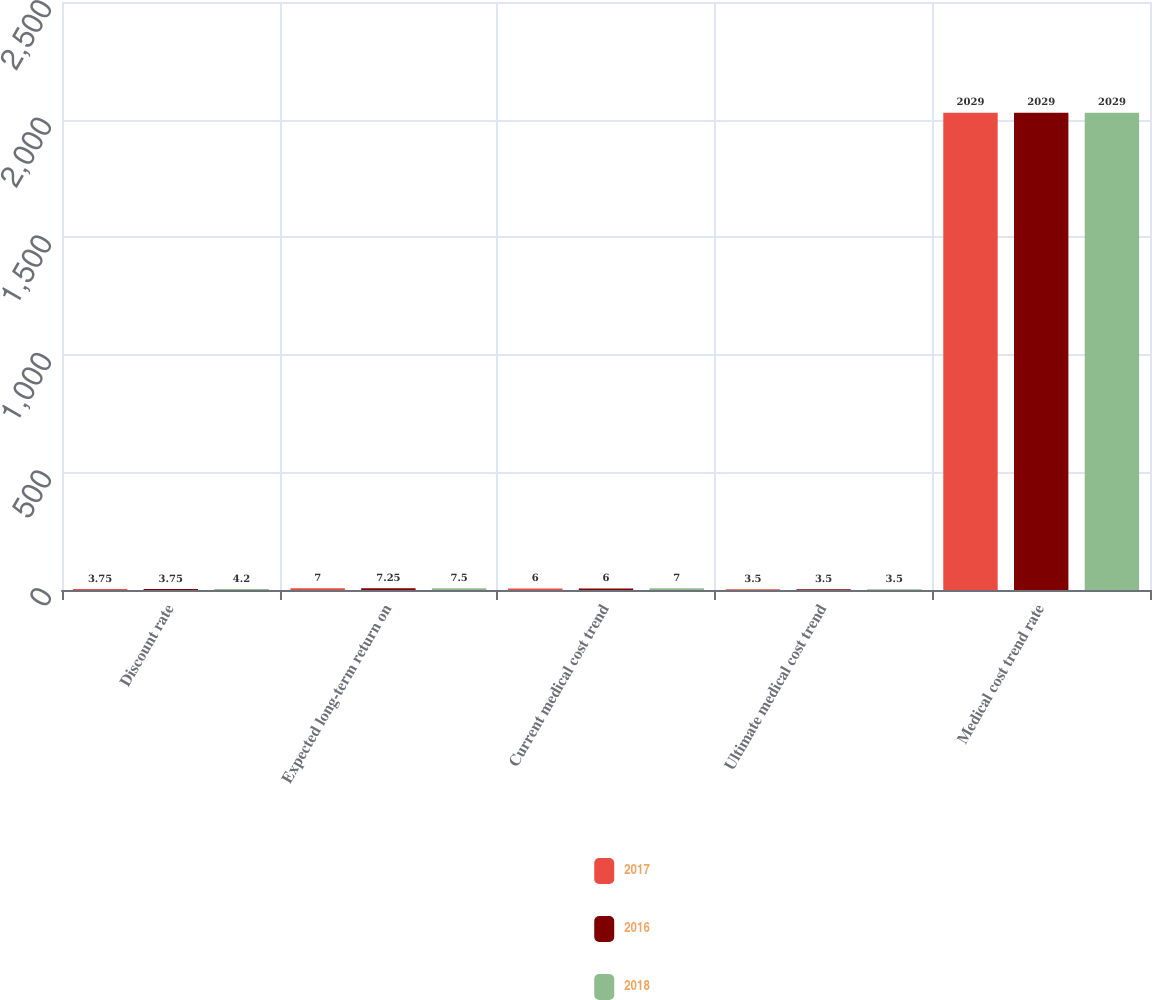Convert chart. <chart><loc_0><loc_0><loc_500><loc_500><stacked_bar_chart><ecel><fcel>Discount rate<fcel>Expected long-term return on<fcel>Current medical cost trend<fcel>Ultimate medical cost trend<fcel>Medical cost trend rate<nl><fcel>2017<fcel>3.75<fcel>7<fcel>6<fcel>3.5<fcel>2029<nl><fcel>2016<fcel>3.75<fcel>7.25<fcel>6<fcel>3.5<fcel>2029<nl><fcel>2018<fcel>4.2<fcel>7.5<fcel>7<fcel>3.5<fcel>2029<nl></chart> 